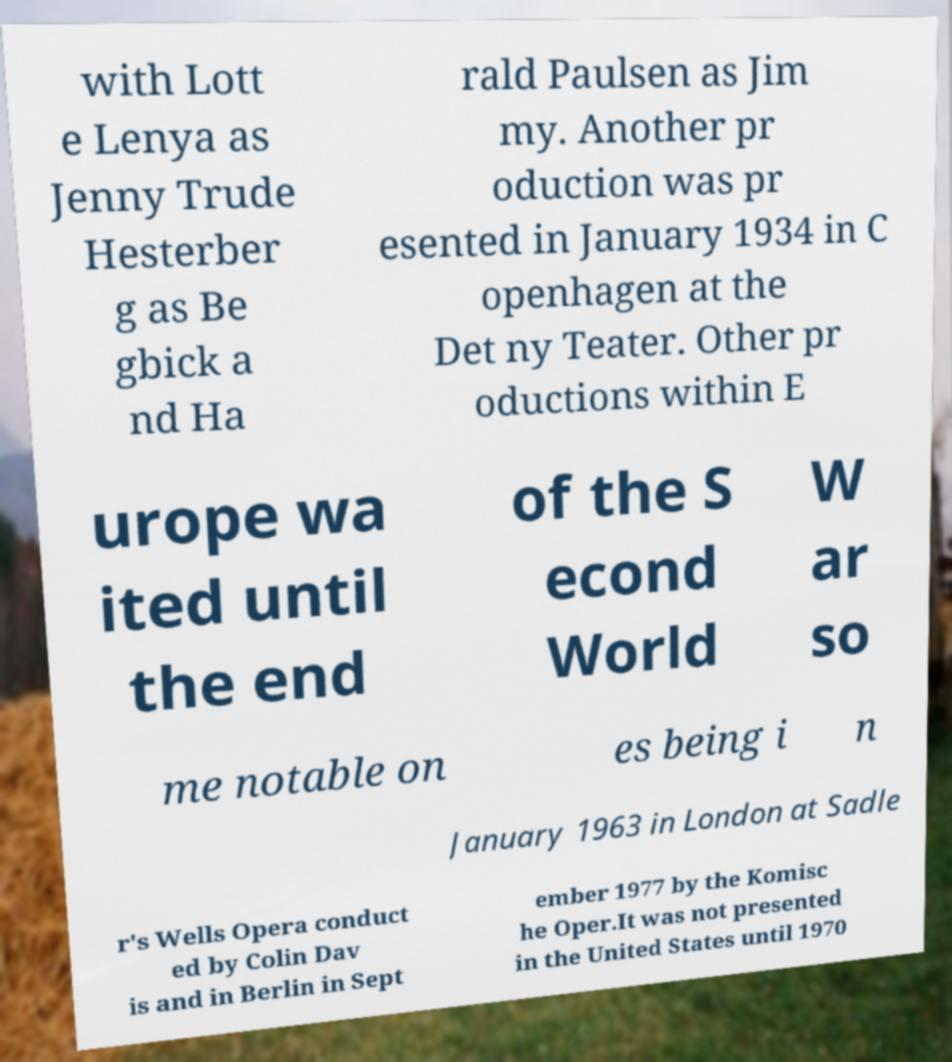I need the written content from this picture converted into text. Can you do that? with Lott e Lenya as Jenny Trude Hesterber g as Be gbick a nd Ha rald Paulsen as Jim my. Another pr oduction was pr esented in January 1934 in C openhagen at the Det ny Teater. Other pr oductions within E urope wa ited until the end of the S econd World W ar so me notable on es being i n January 1963 in London at Sadle r's Wells Opera conduct ed by Colin Dav is and in Berlin in Sept ember 1977 by the Komisc he Oper.It was not presented in the United States until 1970 